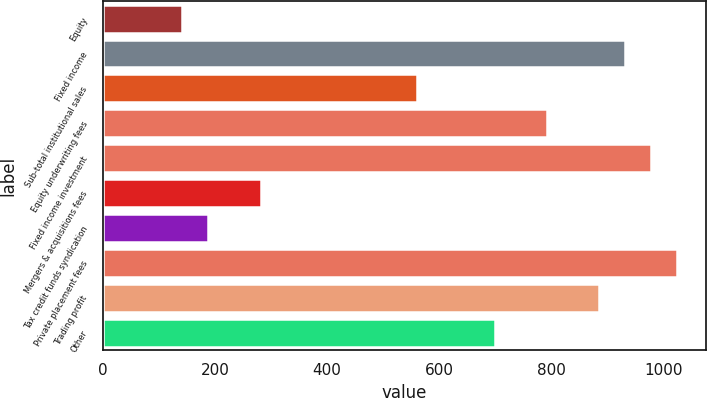Convert chart. <chart><loc_0><loc_0><loc_500><loc_500><bar_chart><fcel>Equity<fcel>Fixed income<fcel>Sub-total institutional sales<fcel>Equity underwriting fees<fcel>Fixed income investment<fcel>Mergers & acquisitions fees<fcel>Tax credit funds syndication<fcel>Private placement fees<fcel>Trading profit<fcel>Other<nl><fcel>142.2<fcel>931<fcel>559.8<fcel>791.8<fcel>977.4<fcel>281.4<fcel>188.6<fcel>1023.8<fcel>884.6<fcel>699<nl></chart> 